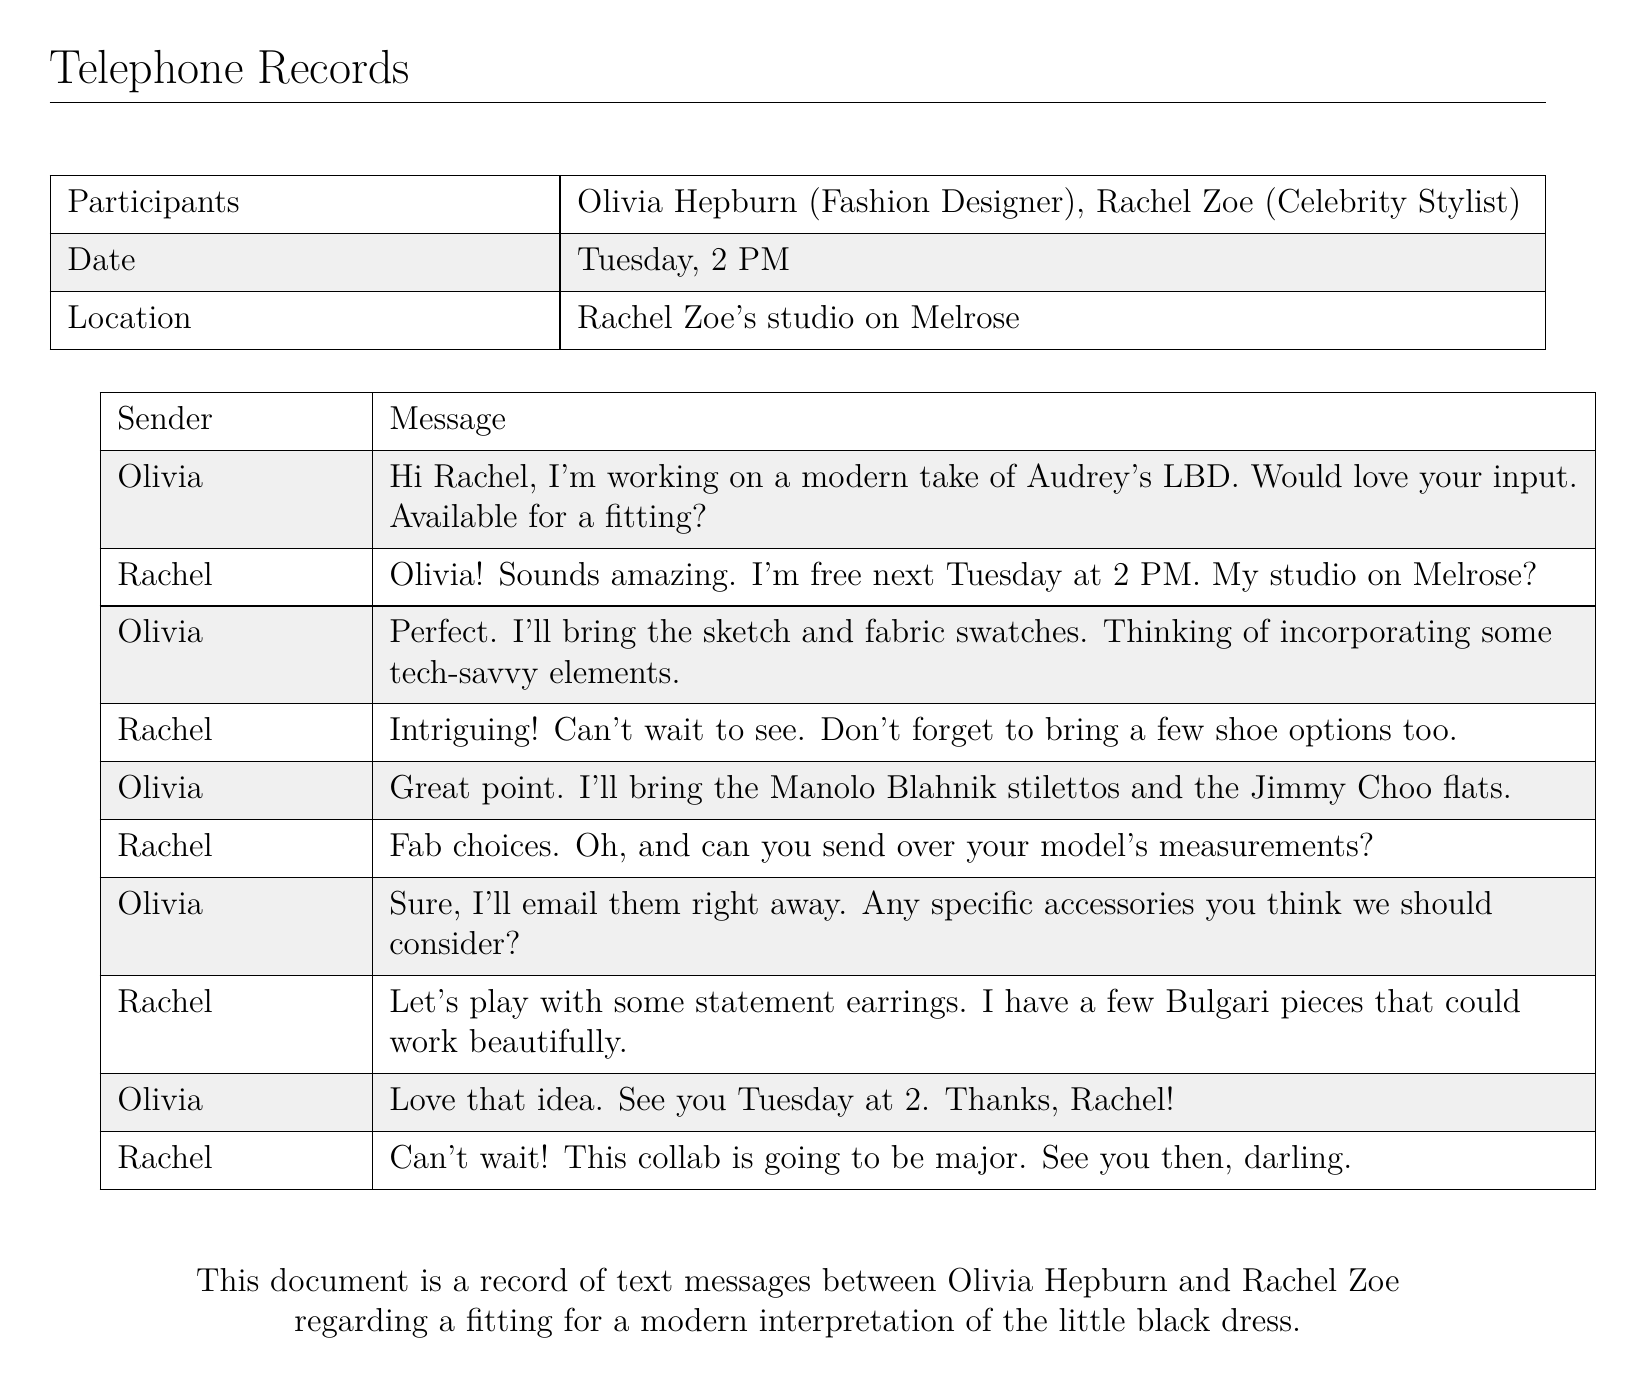What is the date of the fitting? The date is mentioned in the document as next Tuesday at 2 PM.
Answer: Tuesday, 2 PM Who is the celebrity stylist? Rachel Zoe is identified as the celebrity stylist in the document.
Answer: Rachel Zoe What type of dress is Olivia designing? The document states that Olivia is working on a modern interpretation of Audrey's LBD, referring to the little black dress.
Answer: little black dress What will Olivia bring to the fitting? Olivia mentions bringing the sketch and fabric swatches as well as shoe options.
Answer: sketch and fabric swatches What shoes will Olivia bring? The document lists the choices as Manolo Blahnik stilettos and Jimmy Choo flats.
Answer: Manolo Blahnik stilettos and Jimmy Choo flats What measurements does Rachel request? Rachel asks Olivia to send over the model's measurements.
Answer: model's measurements What kind of accessories does Rachel suggest? Rachel suggests playing with statement earrings for the fitting.
Answer: statement earrings What brand does Rachel mention for earrings? The document mentions Bulgari as the brand for the suggested earrings.
Answer: Bulgari What is Olivia’s last name? The document states her full name as Olivia Hepburn.
Answer: Hepburn 